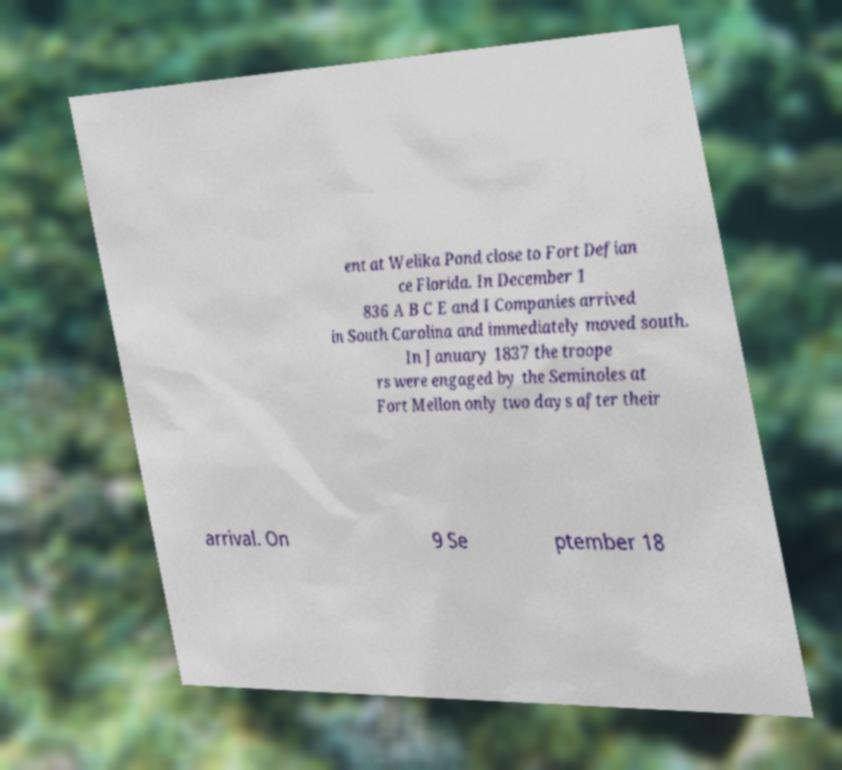Please identify and transcribe the text found in this image. ent at Welika Pond close to Fort Defian ce Florida. In December 1 836 A B C E and I Companies arrived in South Carolina and immediately moved south. In January 1837 the troope rs were engaged by the Seminoles at Fort Mellon only two days after their arrival. On 9 Se ptember 18 